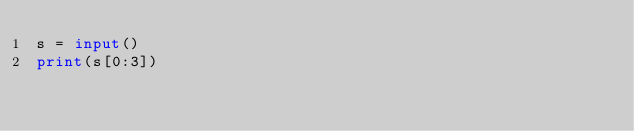<code> <loc_0><loc_0><loc_500><loc_500><_Python_>s = input()
print(s[0:3])</code> 